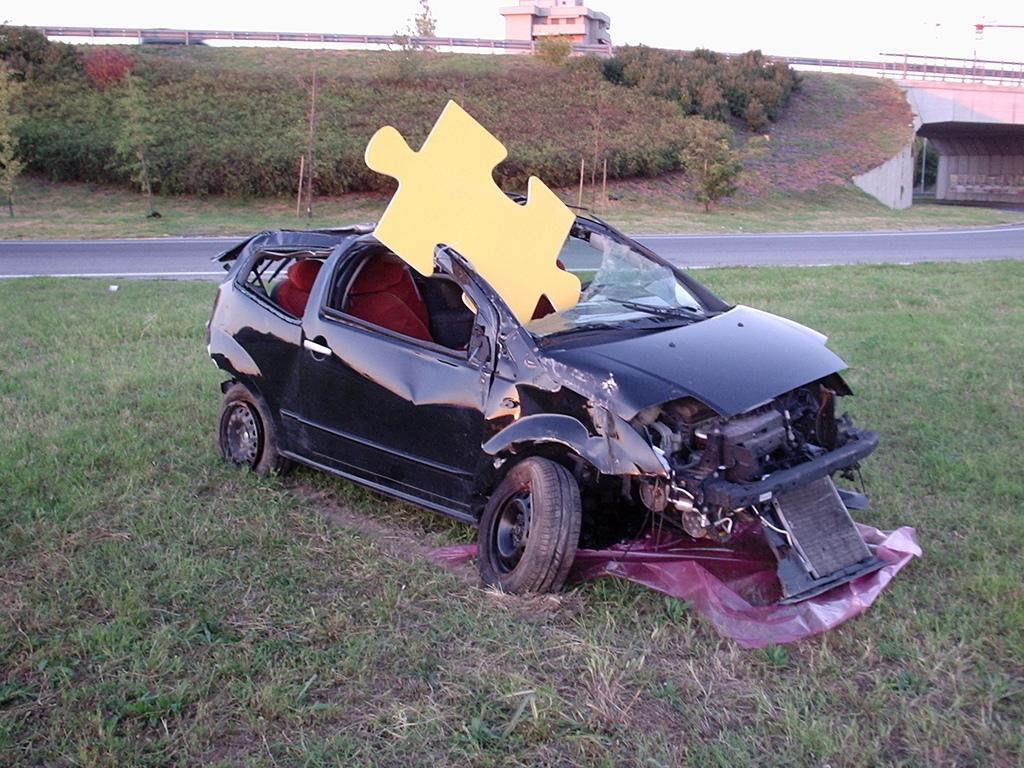How would you summarize this image in a sentence or two? In this image we can see a black color damage car in kept on the surface of grassy land. Behind road and plants are there. Background of the image one building is present. 